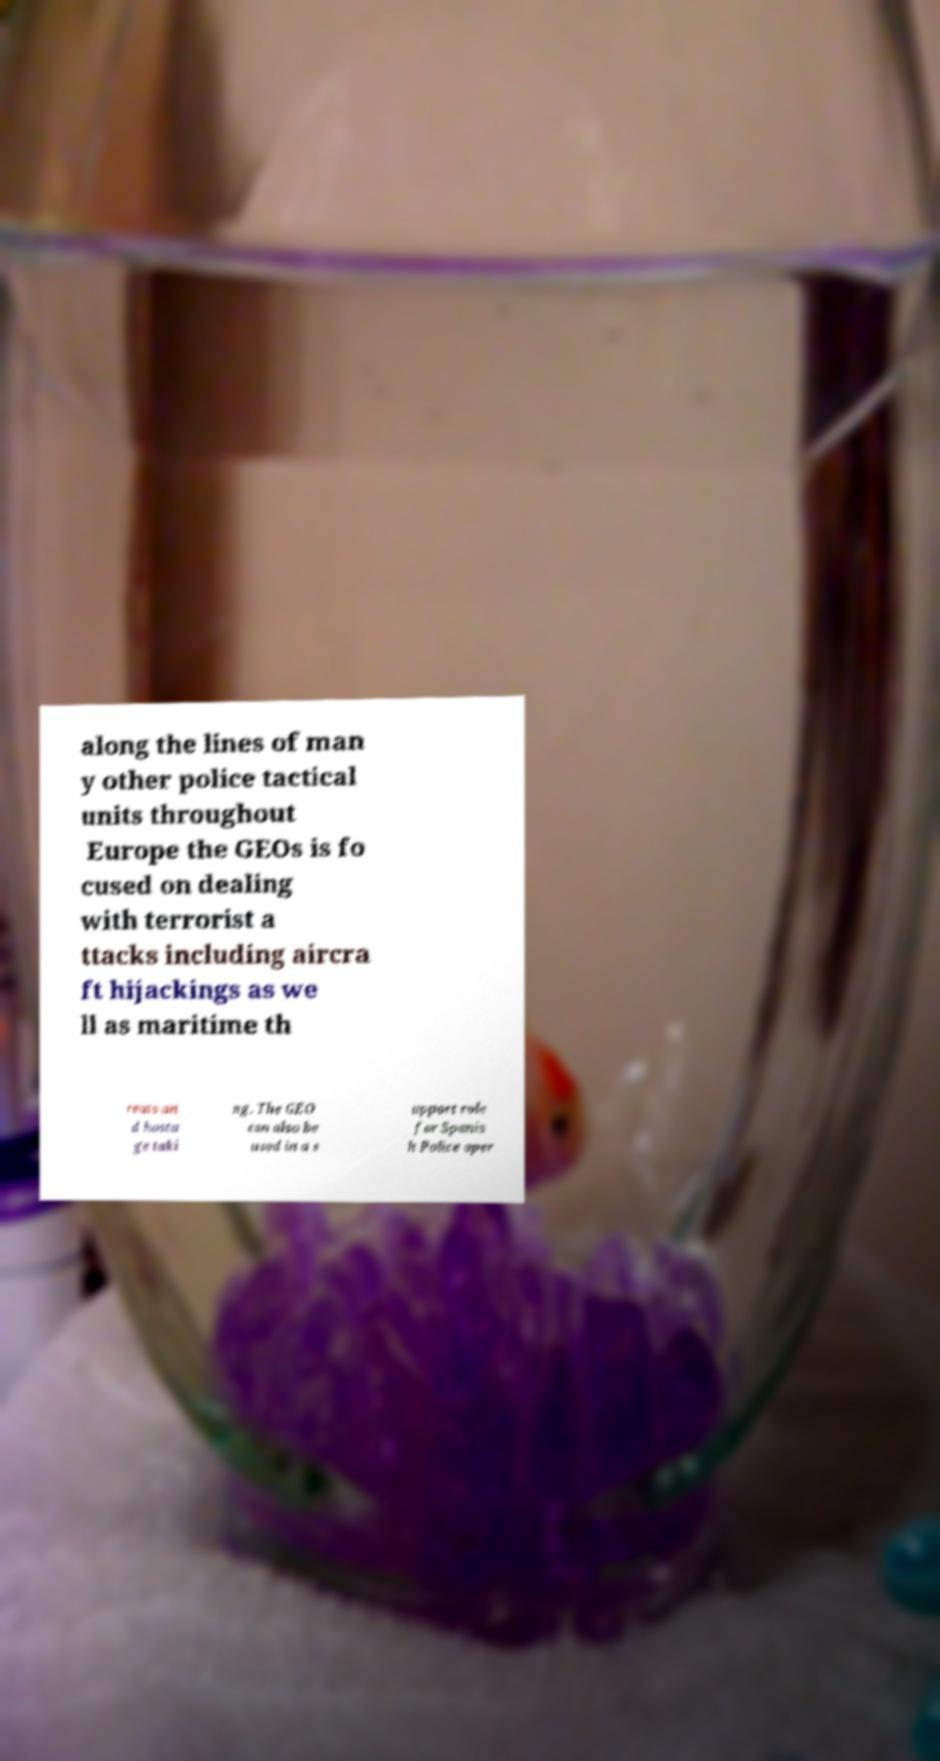I need the written content from this picture converted into text. Can you do that? along the lines of man y other police tactical units throughout Europe the GEOs is fo cused on dealing with terrorist a ttacks including aircra ft hijackings as we ll as maritime th reats an d hosta ge taki ng. The GEO can also be used in a s upport role for Spanis h Police oper 